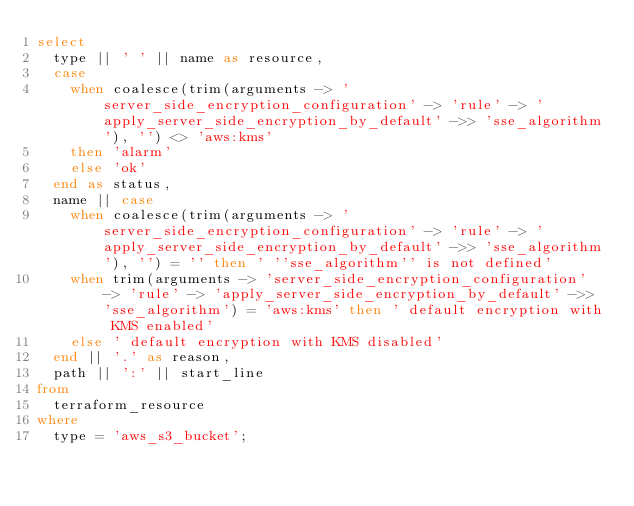Convert code to text. <code><loc_0><loc_0><loc_500><loc_500><_SQL_>select
  type || ' ' || name as resource,
  case
    when coalesce(trim(arguments -> 'server_side_encryption_configuration' -> 'rule' -> 'apply_server_side_encryption_by_default' ->> 'sse_algorithm'), '') <> 'aws:kms'
    then 'alarm'
    else 'ok'
  end as status,
  name || case
    when coalesce(trim(arguments -> 'server_side_encryption_configuration' -> 'rule' -> 'apply_server_side_encryption_by_default' ->> 'sse_algorithm'), '') = '' then ' ''sse_algorithm'' is not defined'
    when trim(arguments -> 'server_side_encryption_configuration' -> 'rule' -> 'apply_server_side_encryption_by_default' ->> 'sse_algorithm') = 'aws:kms' then ' default encryption with KMS enabled'
    else ' default encryption with KMS disabled'
  end || '.' as reason,
  path || ':' || start_line
from
  terraform_resource
where
  type = 'aws_s3_bucket';</code> 